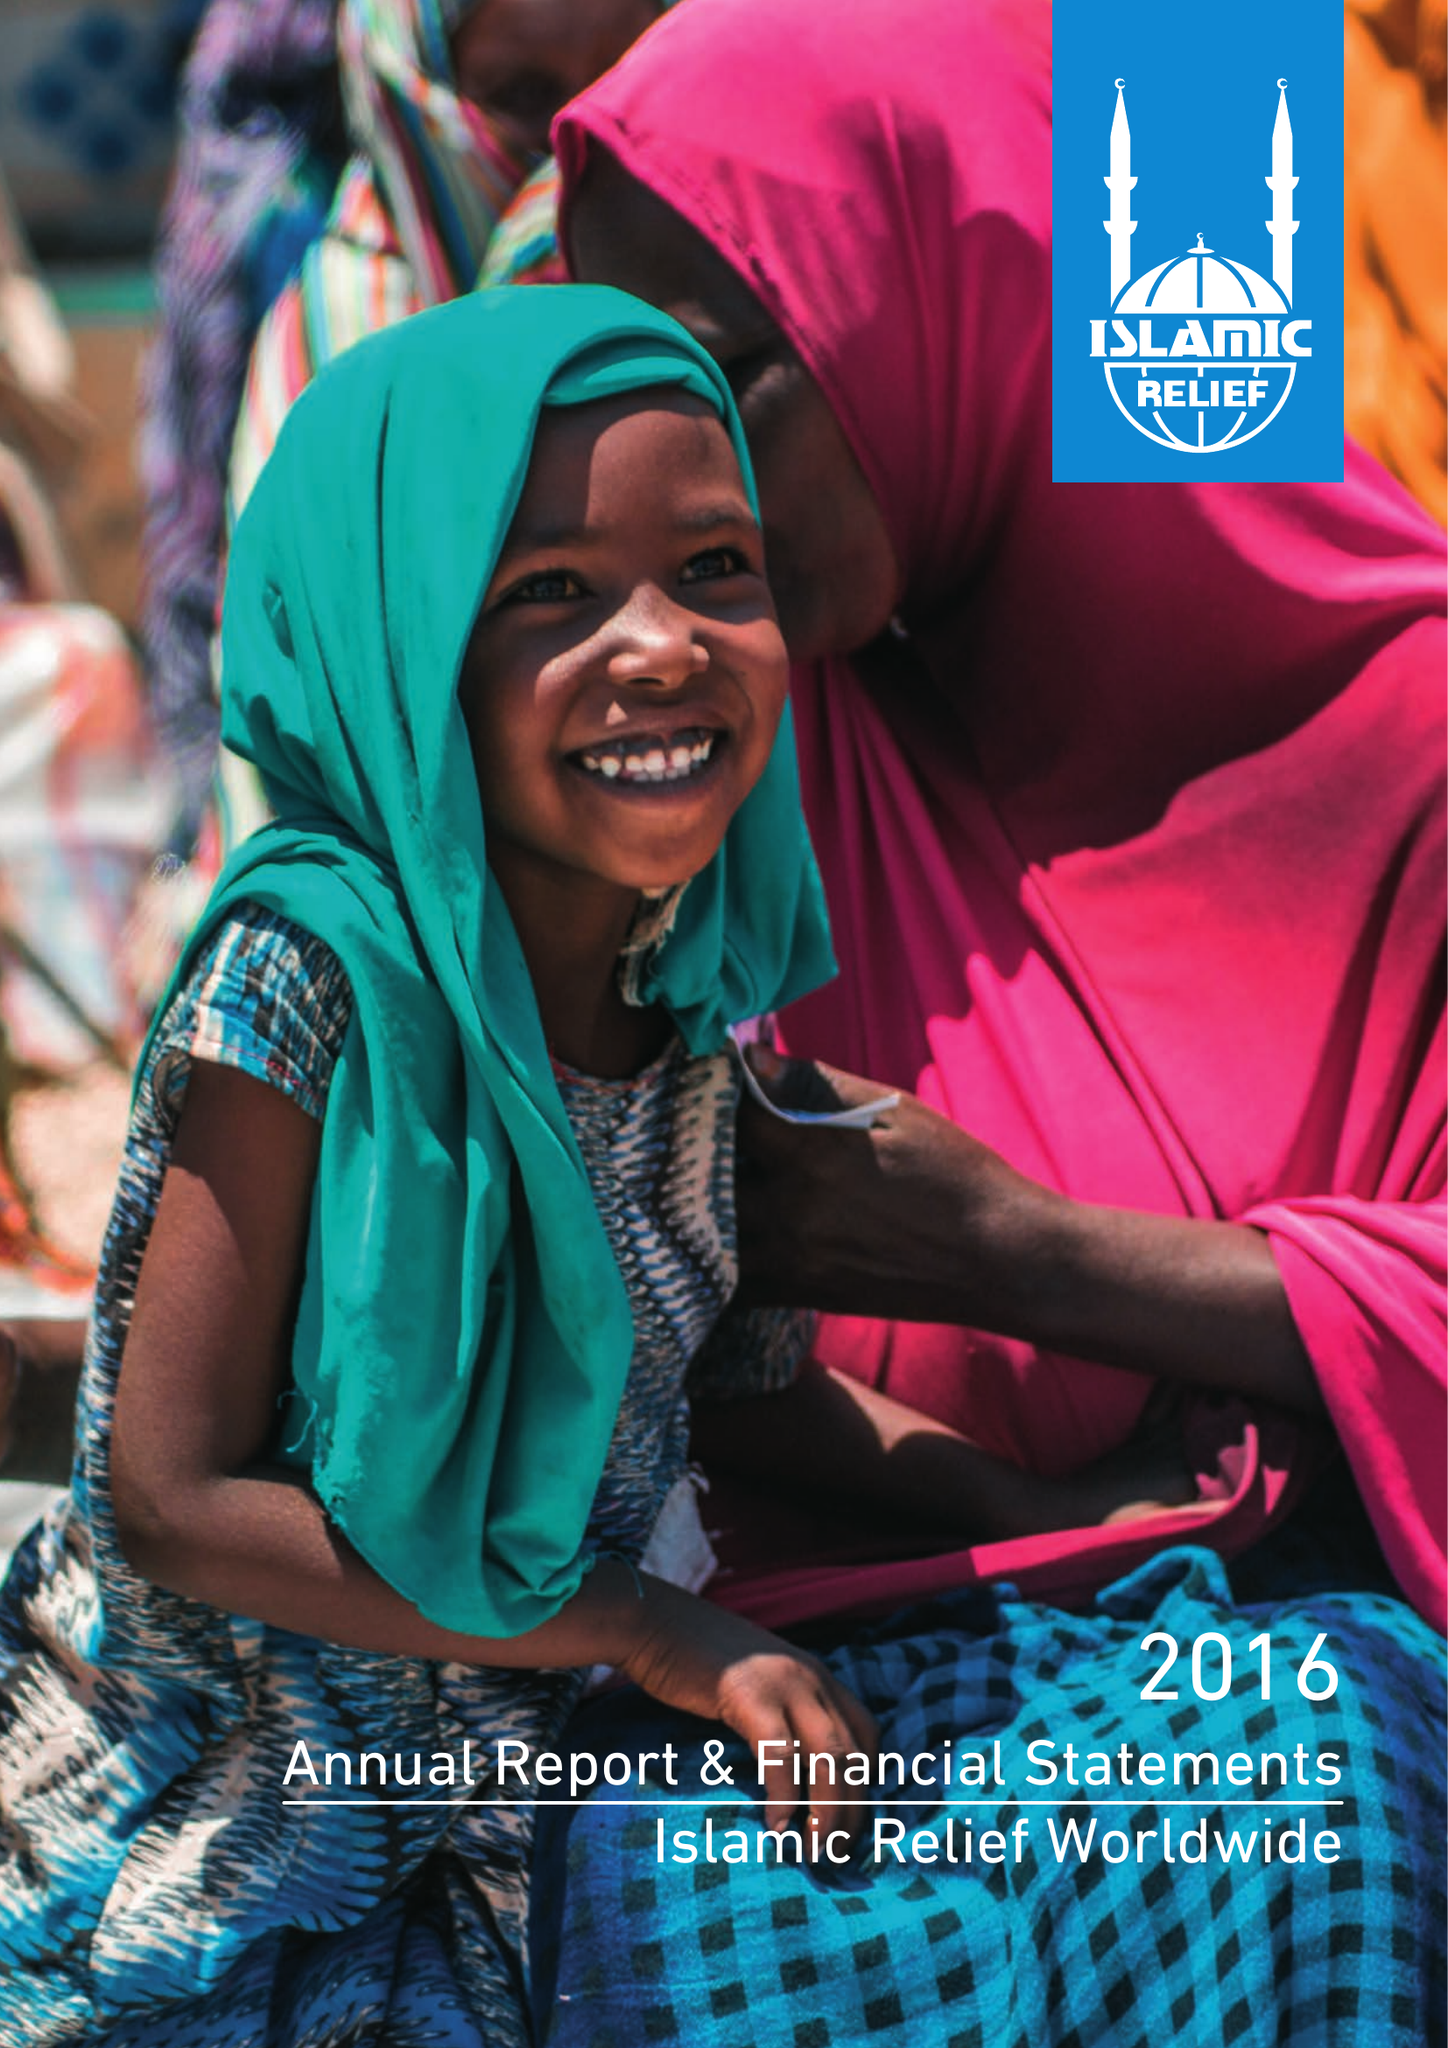What is the value for the address__post_town?
Answer the question using a single word or phrase. BIRMINGHAM 